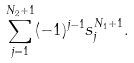<formula> <loc_0><loc_0><loc_500><loc_500>\sum _ { j = 1 } ^ { N _ { 2 } + 1 } ( - 1 ) ^ { j - 1 } s _ { j } ^ { N _ { 1 } + 1 } .</formula> 